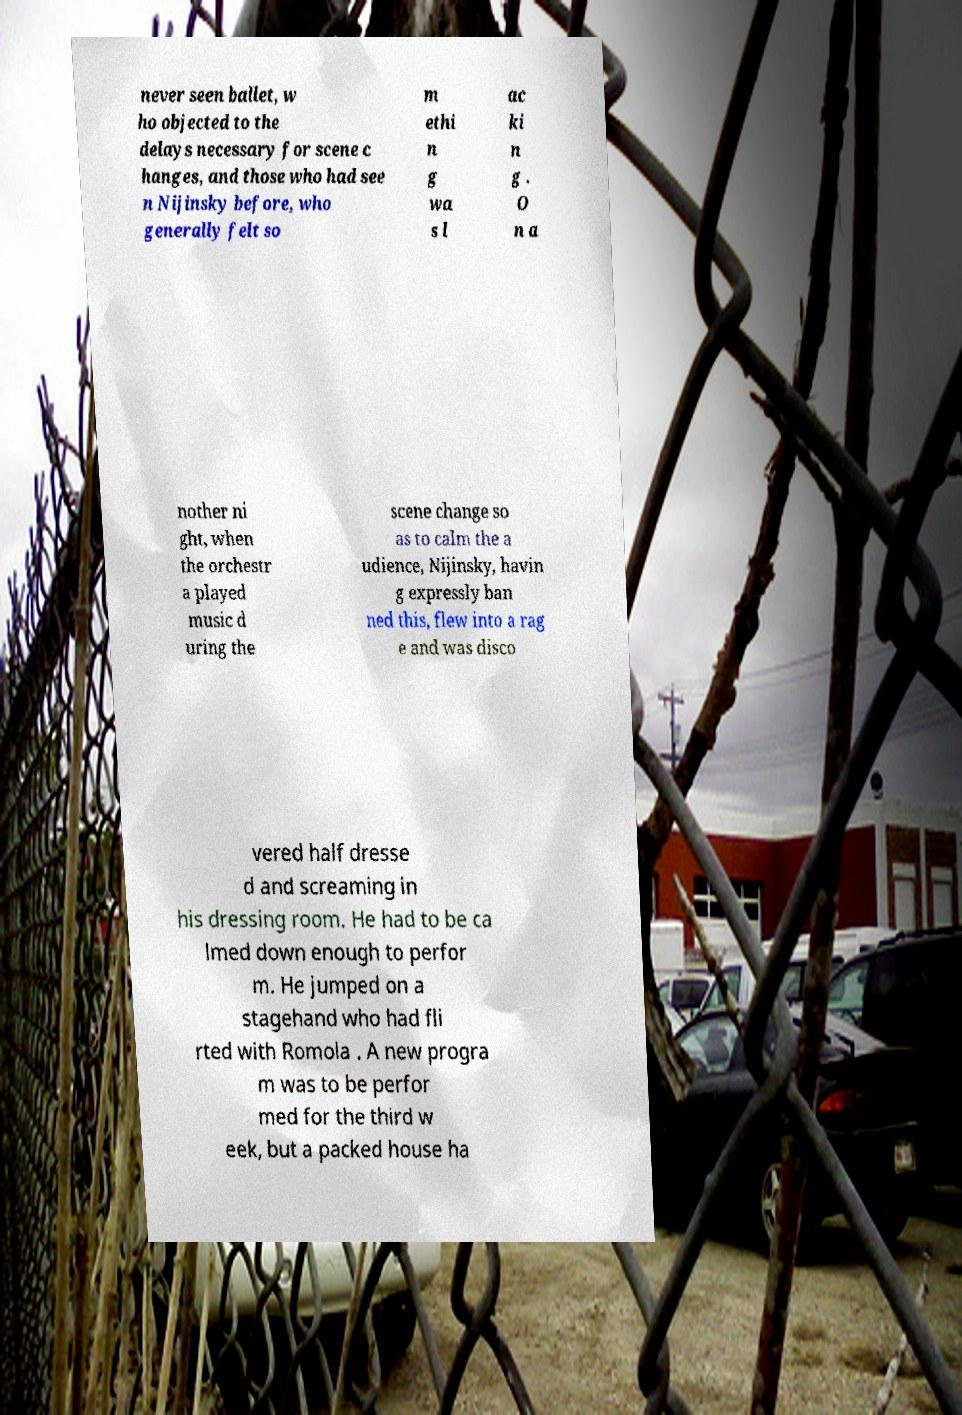Can you accurately transcribe the text from the provided image for me? never seen ballet, w ho objected to the delays necessary for scene c hanges, and those who had see n Nijinsky before, who generally felt so m ethi n g wa s l ac ki n g . O n a nother ni ght, when the orchestr a played music d uring the scene change so as to calm the a udience, Nijinsky, havin g expressly ban ned this, flew into a rag e and was disco vered half dresse d and screaming in his dressing room. He had to be ca lmed down enough to perfor m. He jumped on a stagehand who had fli rted with Romola . A new progra m was to be perfor med for the third w eek, but a packed house ha 